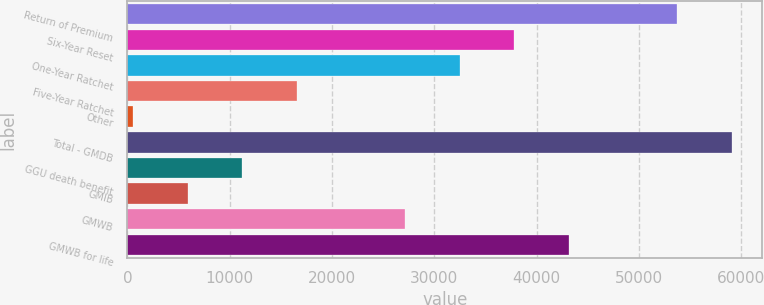<chart> <loc_0><loc_0><loc_500><loc_500><bar_chart><fcel>Return of Premium<fcel>Six-Year Reset<fcel>One-Year Ratchet<fcel>Five-Year Ratchet<fcel>Other<fcel>Total - GMDB<fcel>GGU death benefit<fcel>GMIB<fcel>GMWB<fcel>GMWB for life<nl><fcel>53743<fcel>37794.7<fcel>32478.6<fcel>16530.3<fcel>582<fcel>59059.1<fcel>11214.2<fcel>5898.1<fcel>27162.5<fcel>43110.8<nl></chart> 